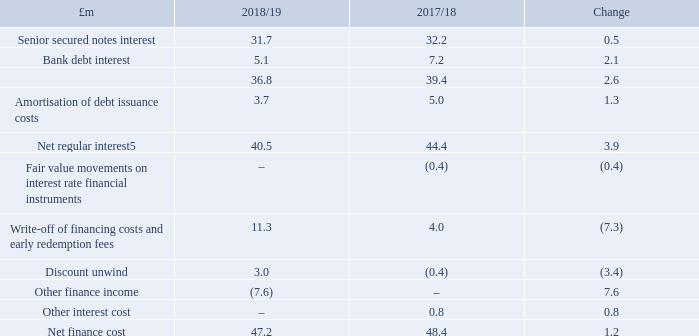Net finance cost was £47.2m for the year; a decrease of £1.2m on 2017/18. Net regular interest in the year was £40.5m, a decrease of £3.9m compared to the prior year. Consistent with recent years, the largest component of finance costs in the year was interest due to holders of the Group’s senior secured notes, which was £31.7m.
The interest on the senior secured notes was £0.5m lower compared to the prior year following the re-financing of the June 2021 £325m fixed rate notes at a coupon of 6.5% to the October 2023 £300m fixed rate notes to the slightly lower coupon of 6.25%. Bank debt interest of £5.1m was £2.1m lower in the year due to lower levels of average debt and a lower margin on the revolving credit facility following the refinancing completed in May 2018. Amortisation of debt issuance costs was £3.7m, £1.3m lower than the prior year due to lower transaction costs associated with the issue of the £300m 6.25% Fixed rate notes compared with the retired £325m 6.5% Fixed rate notes.
Write-off of financing costs and early redemption fees of £11.3m include a £5.7m fee related to the write-off of transaction costs associated with the senior secured fixed rate notes due March 2021, which were repaid during the year, and a £5.6m redemption fee associated with the early call of the March 2021 bond.
In the prior year, a £0.4m discount unwind credit relating to long-term property provisions held by the Group due to an increase in gilt yields was reflected in reported Net finance cost. In 2018/19, a discount unwind charge of £3.0m was included in the Net finance cost of £47.2m. Other interest income of £7.6m in the year relates to monies received from the Group’s associate Hovis Holdings Limited ('Hovis') and reflects the reversal of a previous impairment.
What was the Net finance cost in 2018/19? £47.2m. What was the Net regular interest in 2018/19? £40.5m. What was the Net finance cost in 2017/18?
Answer scale should be: million. 48.4. What is the average Senior secured notes interest, for the year 2018/19 to 2017/18?
Answer scale should be: million. (31.7+32.2) / 2
Answer: 31.95. What is the average Bank debt interest, for the year 2018/19 to 2017/18?
Answer scale should be: million. (5.1+7.2) / 2
Answer: 6.15. What is the average Net regular interest, for the year 2018/19 to 2017/18?
Answer scale should be: million. (40.5+44.4) / 2
Answer: 42.45. 